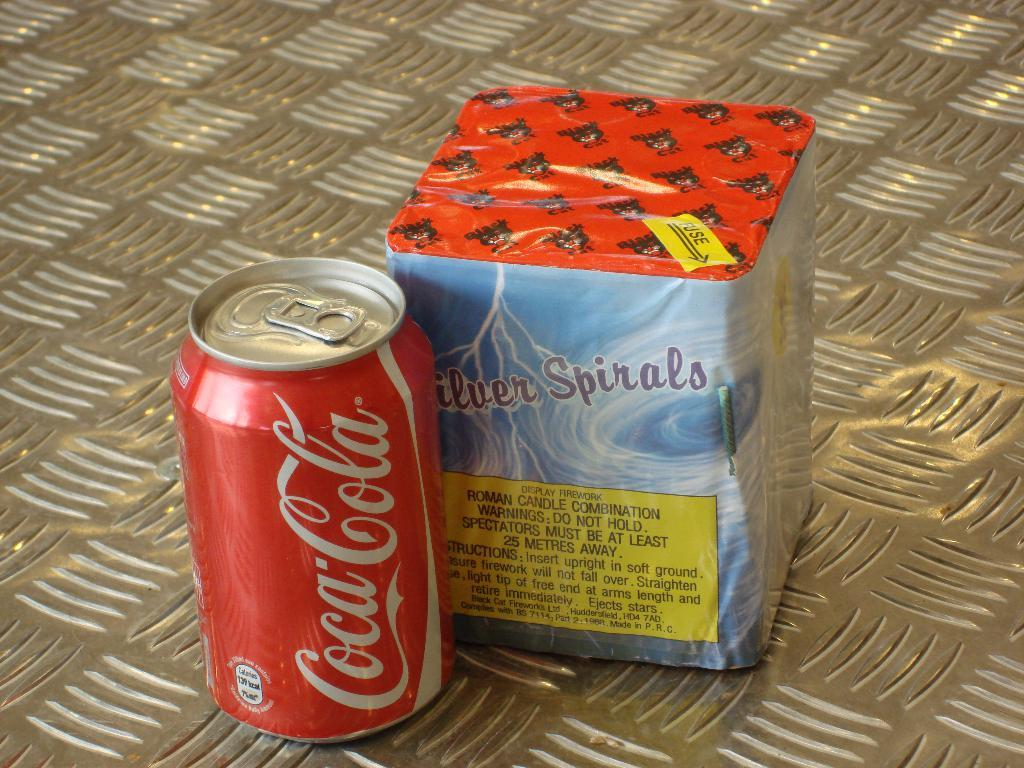<image>
Render a clear and concise summary of the photo. A can of Coca Cola next to a brick of Roman Candle combination fireworks. 